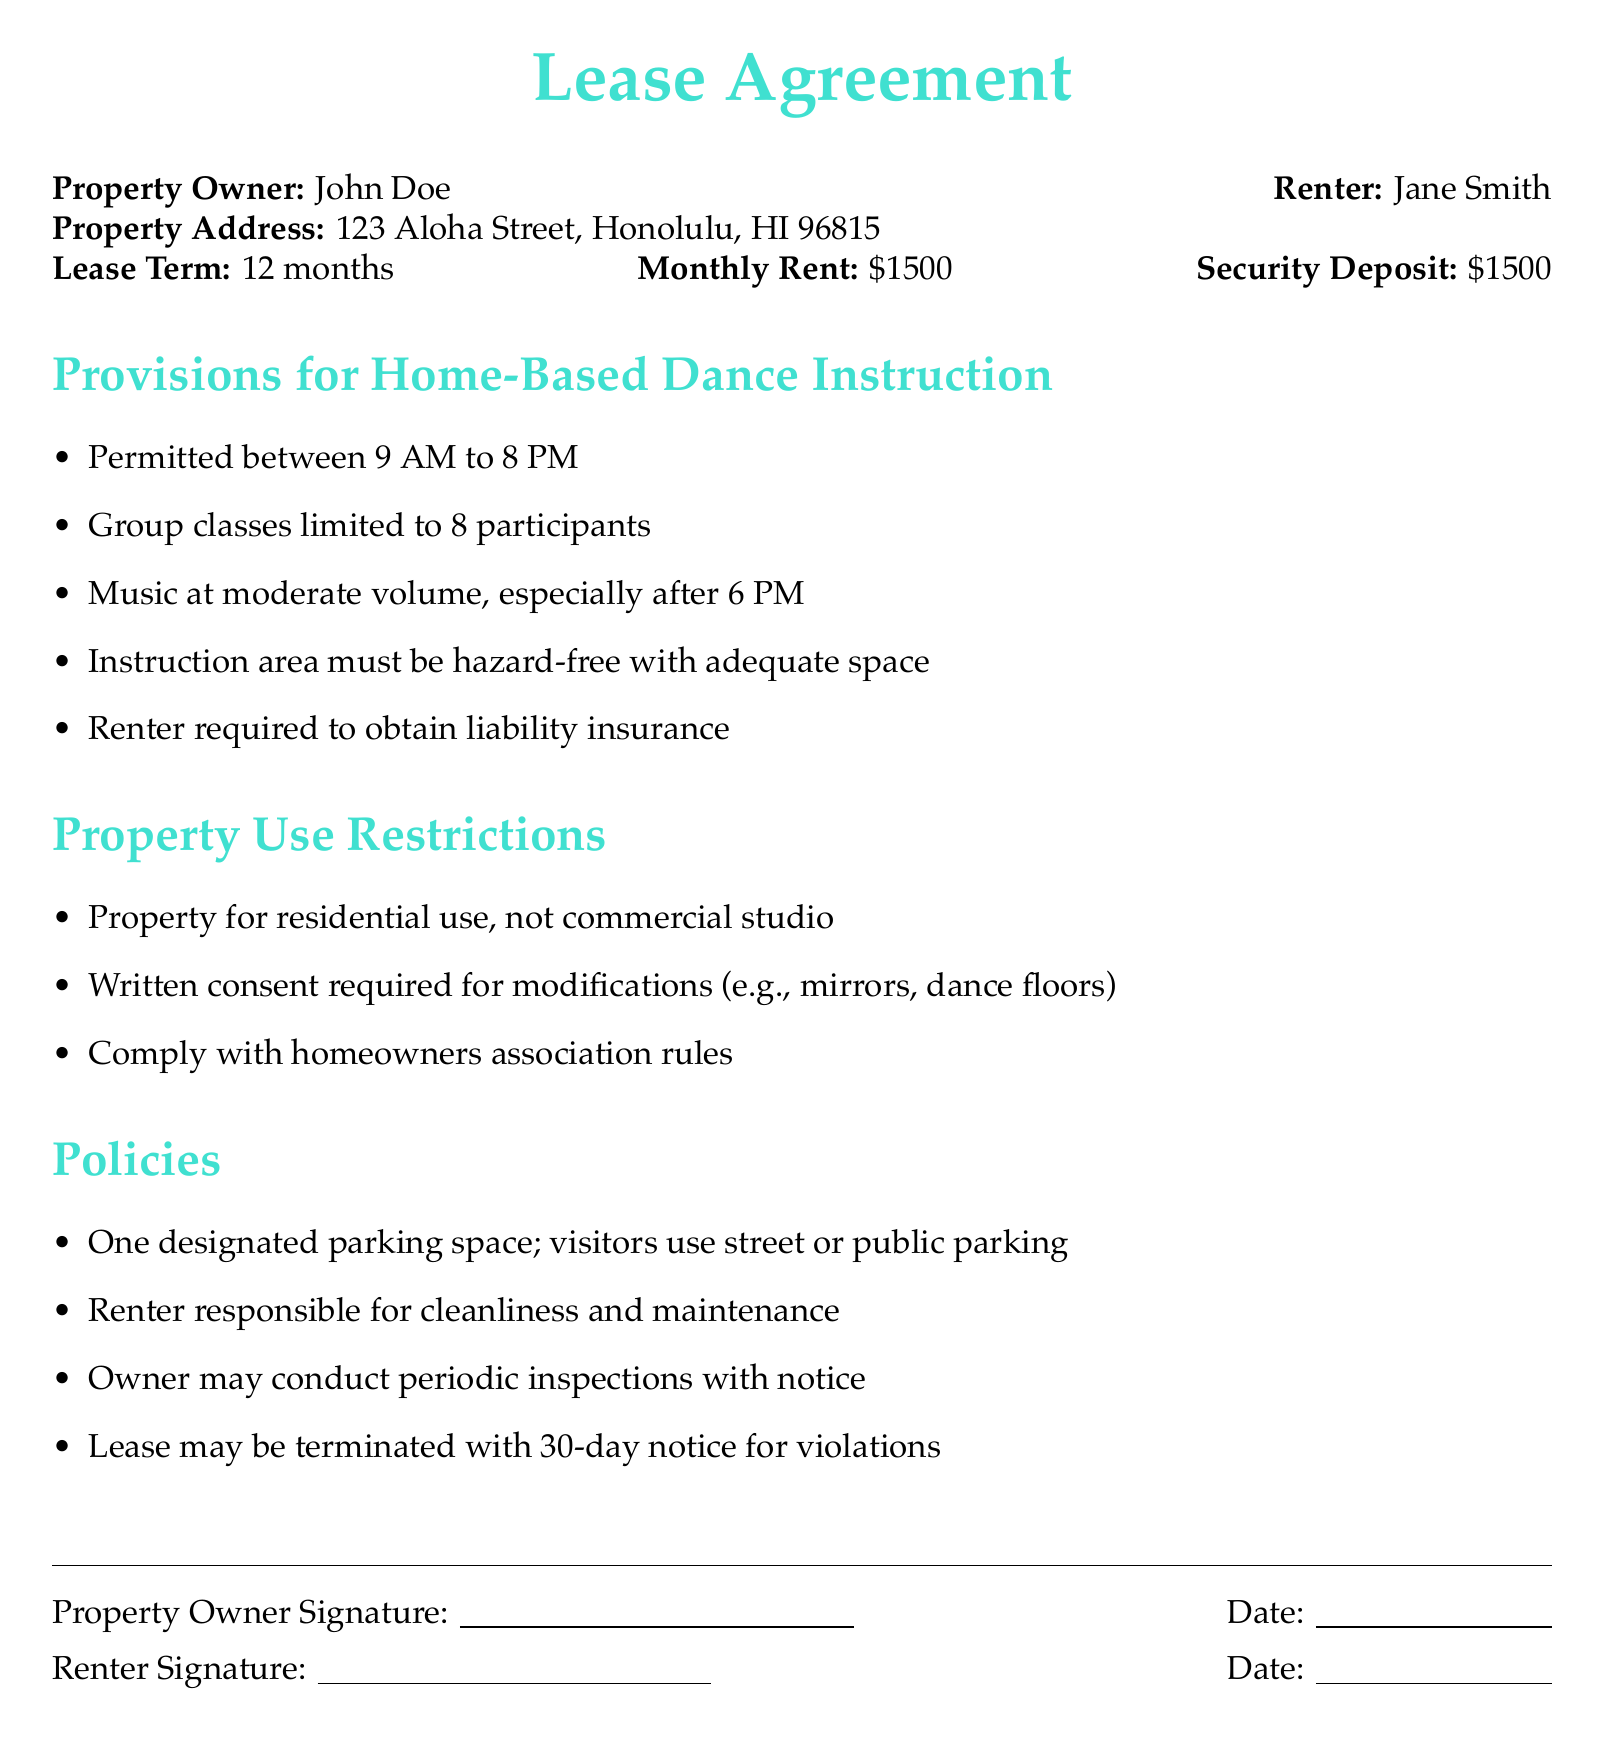What is the name of the property owner? The property owner is identified in the document as John Doe.
Answer: John Doe What is the monthly rent amount? The document explicitly states the monthly rent, which is given as 1500 dollars.
Answer: $1500 What is the maximum number of participants allowed in group classes? The lease specifies that group classes are limited to 8 participants.
Answer: 8 participants What time can home-based dance instruction start? The instructions in the provisions indicate that permitted hours start at 9 AM.
Answer: 9 AM What is required from the renter regarding insurance? The document states that the renter is required to obtain liability insurance for the dance instruction.
Answer: Liability insurance What must happen if the renter wants to make modifications to the property? The lease states that written consent is required for any modifications made to the property.
Answer: Written consent How much notice is required to terminate the lease for violations? According to the policies, a notice of 30 days is required to terminate the lease for violations.
Answer: 30 days What type of use is the property restricted to? The document specifies that the property is for residential use only.
Answer: Residential use How many parking spaces are designated for the renter? The policy indicates that there is one designated parking space for the renter.
Answer: One designated parking space 